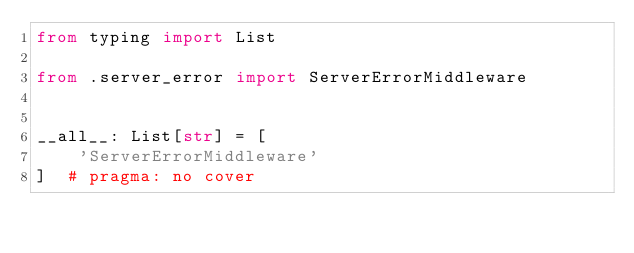Convert code to text. <code><loc_0><loc_0><loc_500><loc_500><_Python_>from typing import List

from .server_error import ServerErrorMiddleware


__all__: List[str] = [
    'ServerErrorMiddleware'
]  # pragma: no cover
</code> 